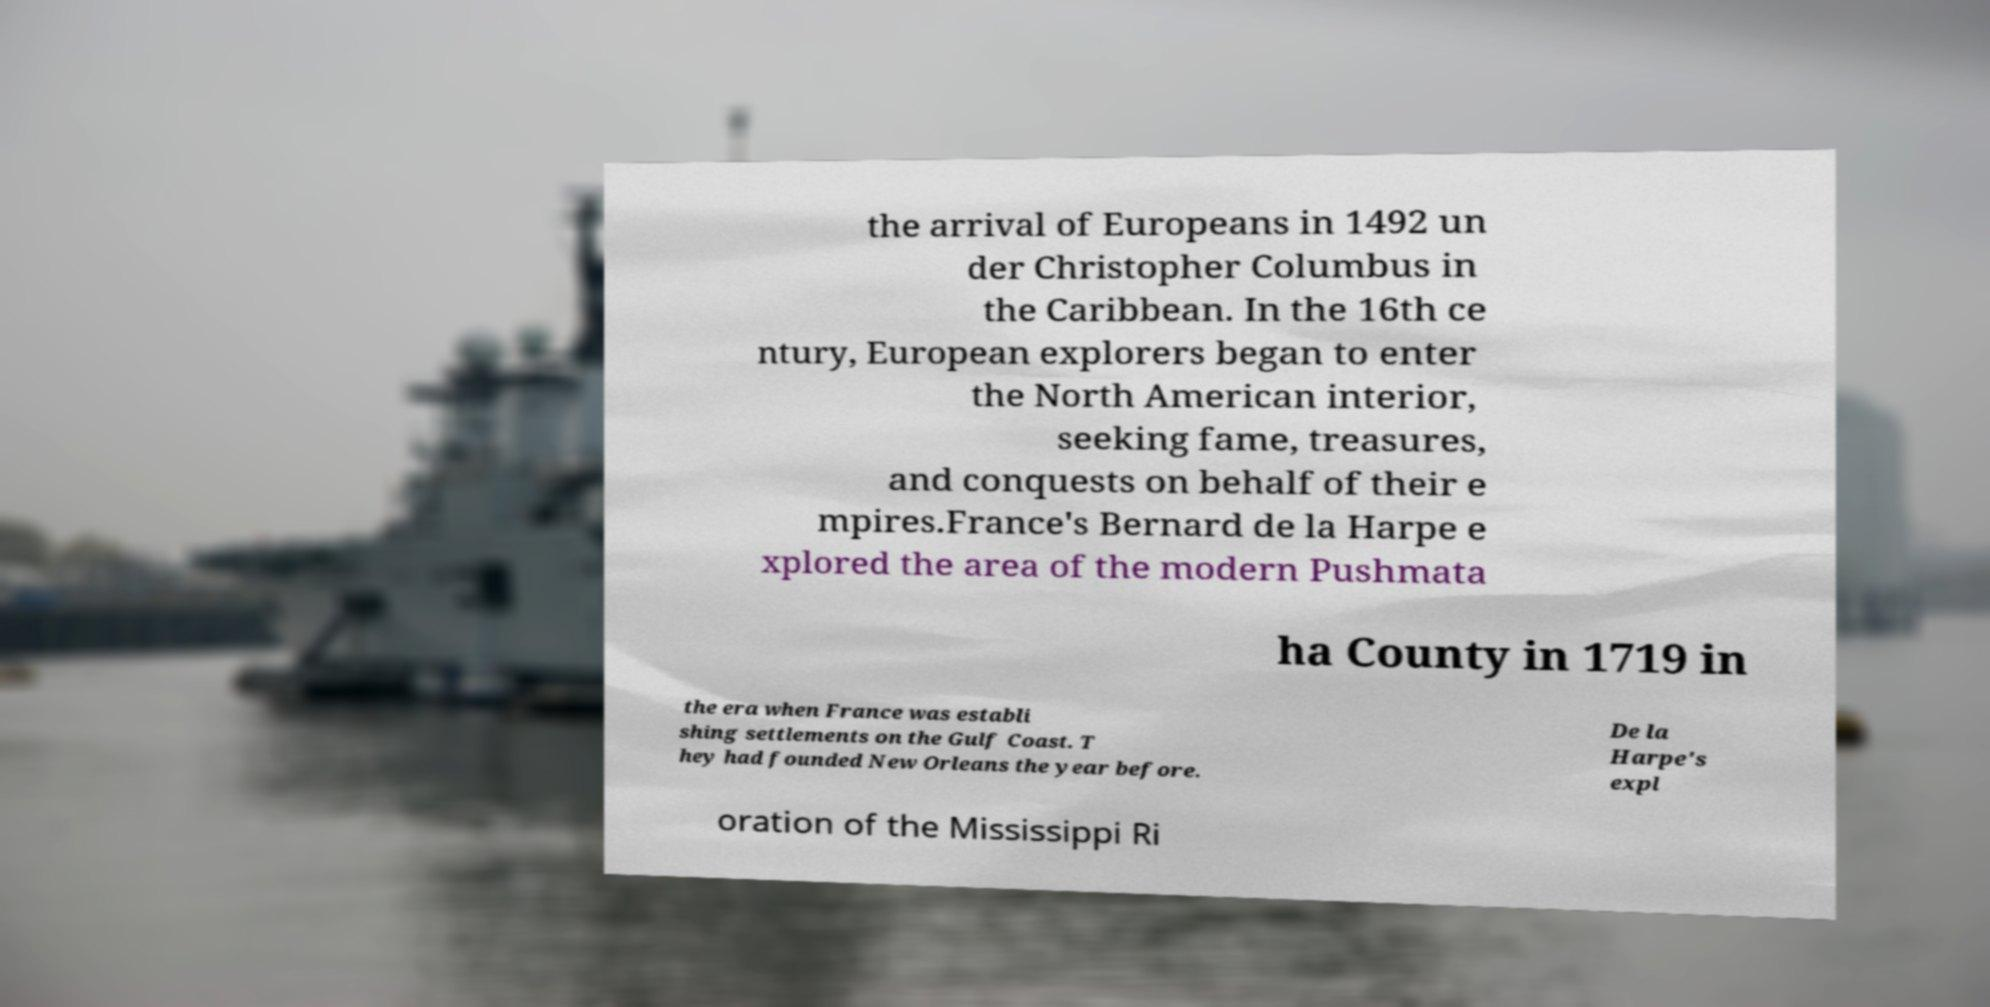I need the written content from this picture converted into text. Can you do that? the arrival of Europeans in 1492 un der Christopher Columbus in the Caribbean. In the 16th ce ntury, European explorers began to enter the North American interior, seeking fame, treasures, and conquests on behalf of their e mpires.France's Bernard de la Harpe e xplored the area of the modern Pushmata ha County in 1719 in the era when France was establi shing settlements on the Gulf Coast. T hey had founded New Orleans the year before. De la Harpe's expl oration of the Mississippi Ri 